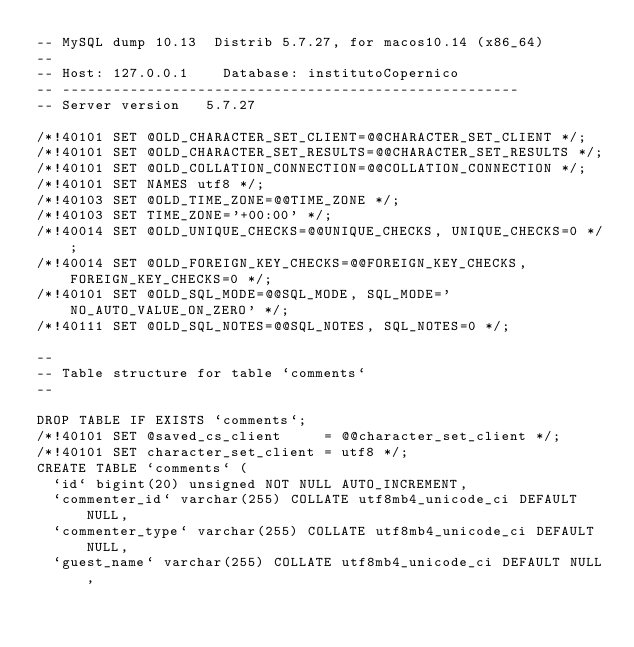<code> <loc_0><loc_0><loc_500><loc_500><_SQL_>-- MySQL dump 10.13  Distrib 5.7.27, for macos10.14 (x86_64)
--
-- Host: 127.0.0.1    Database: institutoCopernico
-- ------------------------------------------------------
-- Server version	5.7.27

/*!40101 SET @OLD_CHARACTER_SET_CLIENT=@@CHARACTER_SET_CLIENT */;
/*!40101 SET @OLD_CHARACTER_SET_RESULTS=@@CHARACTER_SET_RESULTS */;
/*!40101 SET @OLD_COLLATION_CONNECTION=@@COLLATION_CONNECTION */;
/*!40101 SET NAMES utf8 */;
/*!40103 SET @OLD_TIME_ZONE=@@TIME_ZONE */;
/*!40103 SET TIME_ZONE='+00:00' */;
/*!40014 SET @OLD_UNIQUE_CHECKS=@@UNIQUE_CHECKS, UNIQUE_CHECKS=0 */;
/*!40014 SET @OLD_FOREIGN_KEY_CHECKS=@@FOREIGN_KEY_CHECKS, FOREIGN_KEY_CHECKS=0 */;
/*!40101 SET @OLD_SQL_MODE=@@SQL_MODE, SQL_MODE='NO_AUTO_VALUE_ON_ZERO' */;
/*!40111 SET @OLD_SQL_NOTES=@@SQL_NOTES, SQL_NOTES=0 */;

--
-- Table structure for table `comments`
--

DROP TABLE IF EXISTS `comments`;
/*!40101 SET @saved_cs_client     = @@character_set_client */;
/*!40101 SET character_set_client = utf8 */;
CREATE TABLE `comments` (
  `id` bigint(20) unsigned NOT NULL AUTO_INCREMENT,
  `commenter_id` varchar(255) COLLATE utf8mb4_unicode_ci DEFAULT NULL,
  `commenter_type` varchar(255) COLLATE utf8mb4_unicode_ci DEFAULT NULL,
  `guest_name` varchar(255) COLLATE utf8mb4_unicode_ci DEFAULT NULL,</code> 